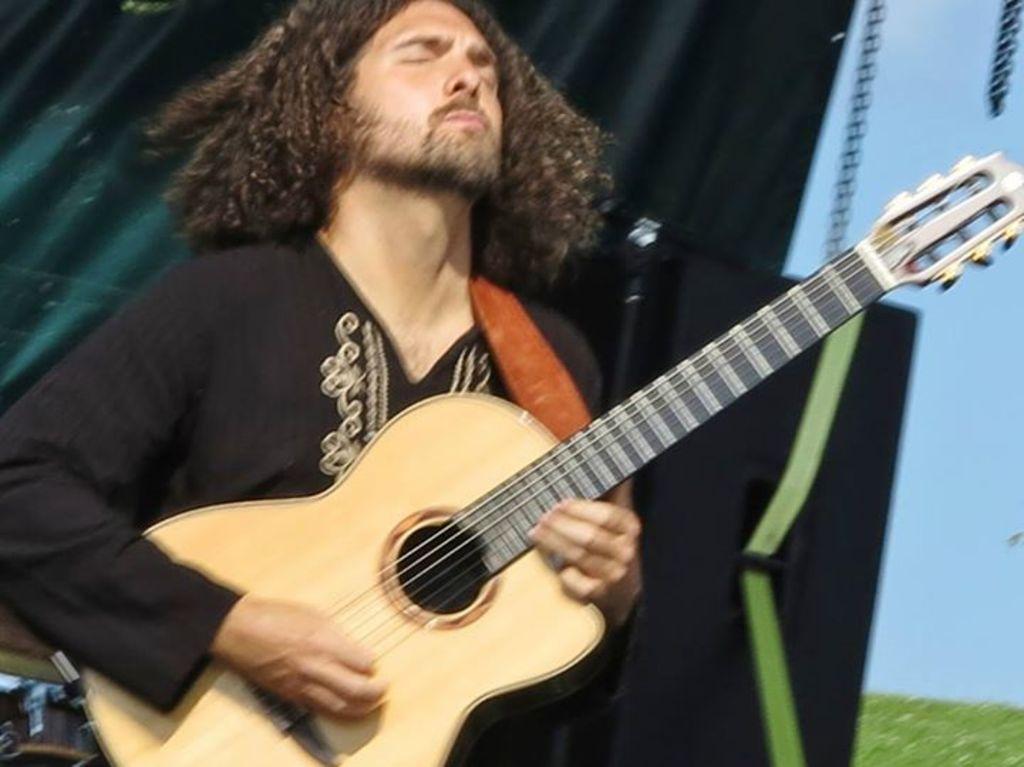Can you describe this image briefly? In this image, a man is holding a guitar. He is playing a music. He wear a black color shirt. And he has a long hair. Beside him, we can see a speaker. And white color banner here and green. On left side , back side of the human , we can see green color cloth. 